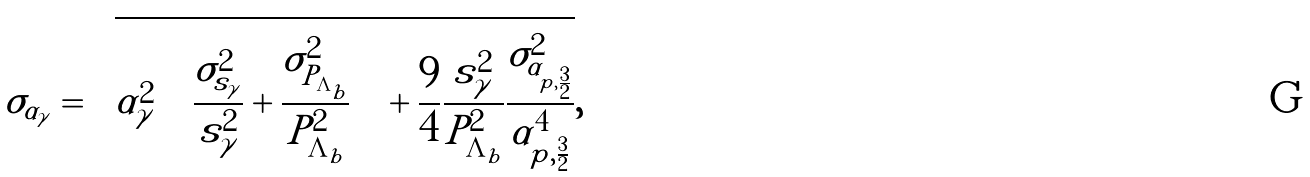<formula> <loc_0><loc_0><loc_500><loc_500>\sigma _ { \alpha _ { \gamma } } = \sqrt { \alpha _ { \gamma } ^ { 2 } \left ( \frac { \sigma _ { s _ { \gamma } } ^ { 2 } } { s _ { \gamma } ^ { 2 } } + \frac { \sigma _ { P _ { \Lambda _ { b } } } ^ { 2 } } { P _ { \Lambda _ { b } } ^ { 2 } } \right ) + \frac { 9 } { 4 } \frac { s _ { \gamma } ^ { 2 } } { P _ { \Lambda _ { b } } ^ { 2 } } \frac { \sigma ^ { 2 } _ { \alpha _ { p , \frac { 3 } { 2 } } } } { \alpha _ { p , \frac { 3 } { 2 } } ^ { 4 } } } ,</formula> 